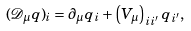<formula> <loc_0><loc_0><loc_500><loc_500>( \mathcal { D } _ { \mu } q ) _ { i } = \partial _ { \mu } q _ { i } + \left ( V _ { \mu } \right ) _ { i i ^ { \prime } } q _ { i ^ { \prime } } ,</formula> 